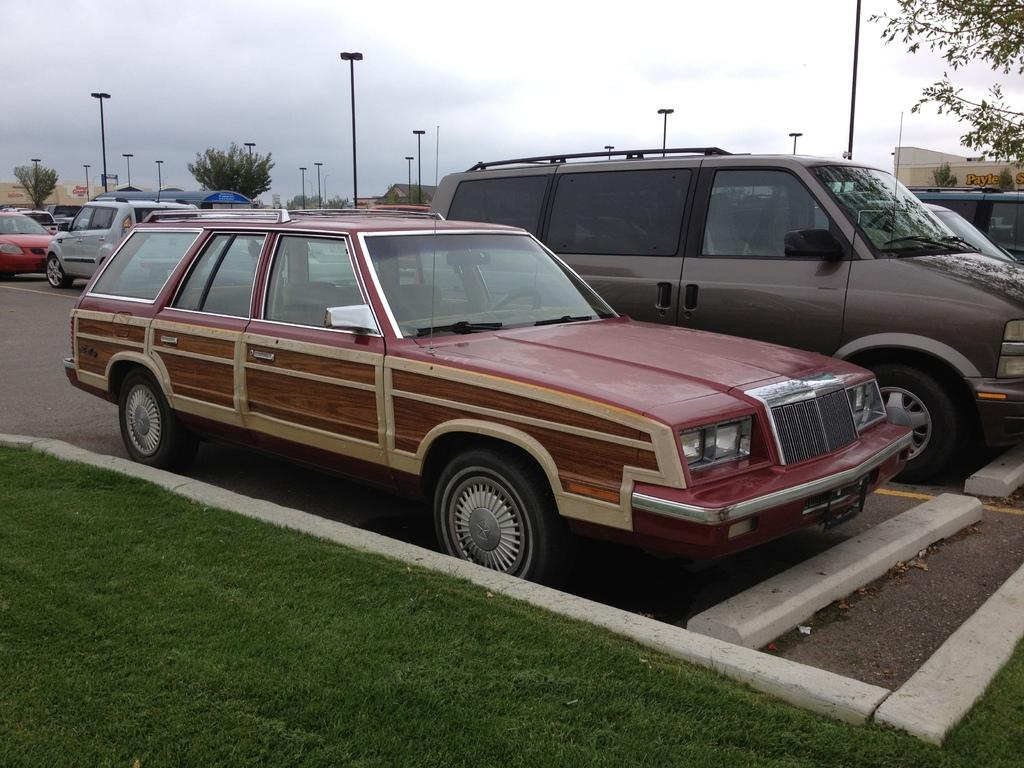What can be seen on the road in the image? There are cars parked on the road in the image. How are the cars arranged on the road? The cars are parked one beside the other. What is present between the parked cars? There are poles between the cars. What type of vegetation is visible at the bottom of the image? Grass is visible at the bottom of the image. What structure can be seen on the right side of the image? There is a building on the right side top of the image. What type of trouble can be seen in the alley behind the building in the image? There is no alley or trouble present in the image; it only shows cars parked on the road with poles between them, grass at the bottom, and a building on the right side. 